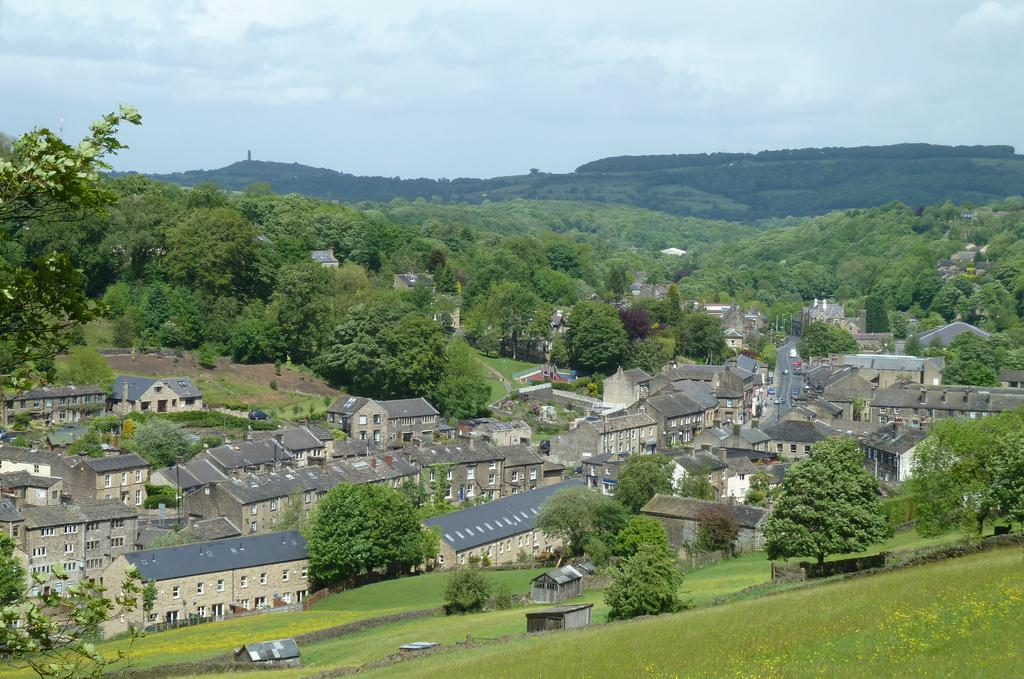What type of structures are visible in the image? There are houses with windows in the image. What can be seen on the hill in the image? The hill appears to have grass on it. What type of vegetation is present in the image? There are trees in the image. What is visible in the distance in the image? In the background, there may be mountains. What mode of transportation might be able to use the road in the image? The road is visible in the image, and it could be used by various types of vehicles. Can you see any beans growing on the hill in the image? There are no beans visible in the image; the hill appears to have grass on it. 